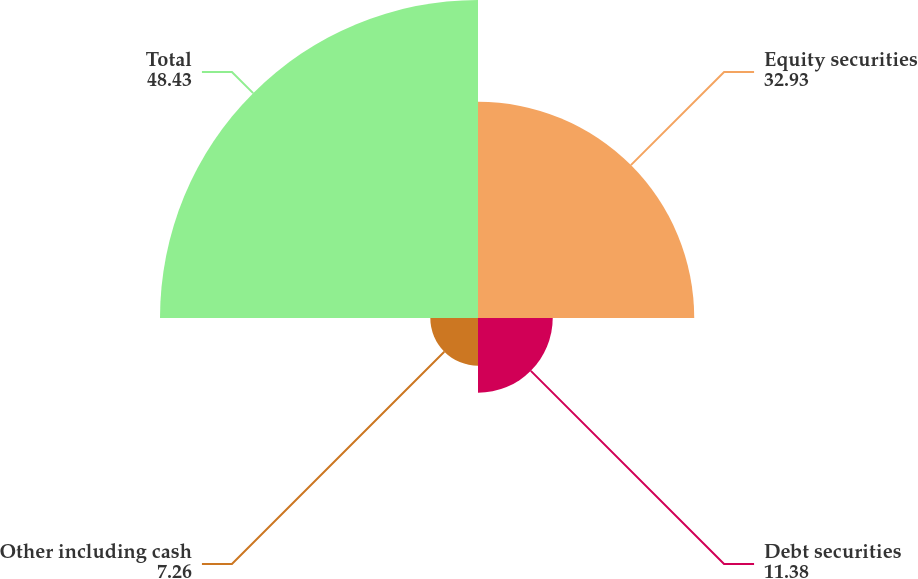Convert chart. <chart><loc_0><loc_0><loc_500><loc_500><pie_chart><fcel>Equity securities<fcel>Debt securities<fcel>Other including cash<fcel>Total<nl><fcel>32.93%<fcel>11.38%<fcel>7.26%<fcel>48.43%<nl></chart> 